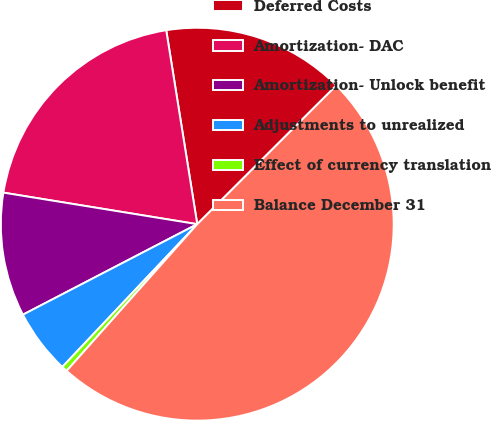<chart> <loc_0><loc_0><loc_500><loc_500><pie_chart><fcel>Deferred Costs<fcel>Amortization- DAC<fcel>Amortization- Unlock benefit<fcel>Adjustments to unrealized<fcel>Effect of currency translation<fcel>Balance December 31<nl><fcel>15.05%<fcel>19.91%<fcel>10.19%<fcel>5.33%<fcel>0.47%<fcel>49.07%<nl></chart> 